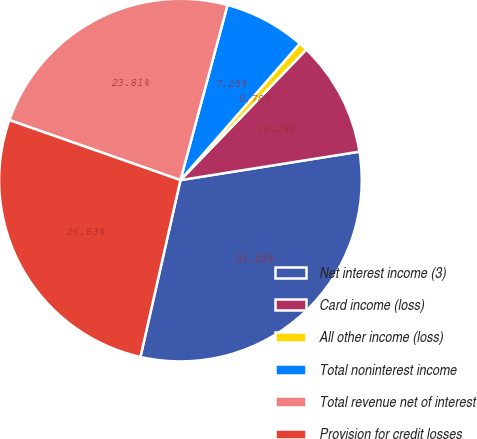<chart> <loc_0><loc_0><loc_500><loc_500><pie_chart><fcel>Net interest income (3)<fcel>Card income (loss)<fcel>All other income (loss)<fcel>Total noninterest income<fcel>Total revenue net of interest<fcel>Provision for credit losses<nl><fcel>31.05%<fcel>10.28%<fcel>0.78%<fcel>7.25%<fcel>23.81%<fcel>26.83%<nl></chart> 